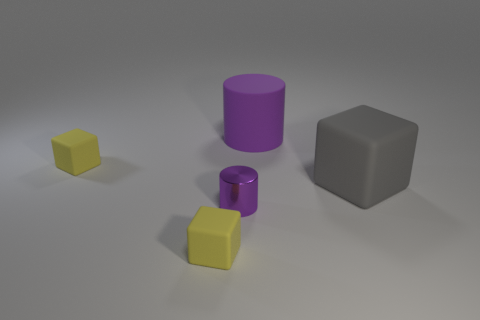Is there any other thing that is the same color as the large block?
Your response must be concise. No. Do the large rubber cylinder and the small metallic object have the same color?
Provide a succinct answer. Yes. Is the number of small yellow matte cubes behind the tiny purple cylinder less than the number of yellow matte balls?
Give a very brief answer. No. How many small purple metallic cylinders are behind the yellow matte cube in front of the gray block?
Give a very brief answer. 1. What number of other things are the same size as the gray cube?
Provide a short and direct response. 1. How many objects are either small blocks or yellow cubes behind the gray block?
Provide a short and direct response. 2. Are there fewer large matte cubes than big cyan rubber cubes?
Make the answer very short. No. What is the color of the tiny block behind the cylinder in front of the big gray cube?
Offer a terse response. Yellow. There is a large purple thing that is the same shape as the small purple object; what material is it?
Offer a terse response. Rubber. How many rubber things are either small purple cylinders or small things?
Offer a very short reply. 2. 